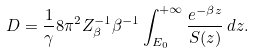<formula> <loc_0><loc_0><loc_500><loc_500>D = \frac { 1 } { \gamma } 8 \pi ^ { 2 } Z _ { \beta } ^ { - 1 } \beta ^ { - 1 } \int _ { E _ { 0 } } ^ { + \infty } \frac { e ^ { - \beta z } } { S ( z ) } \, d z .</formula> 